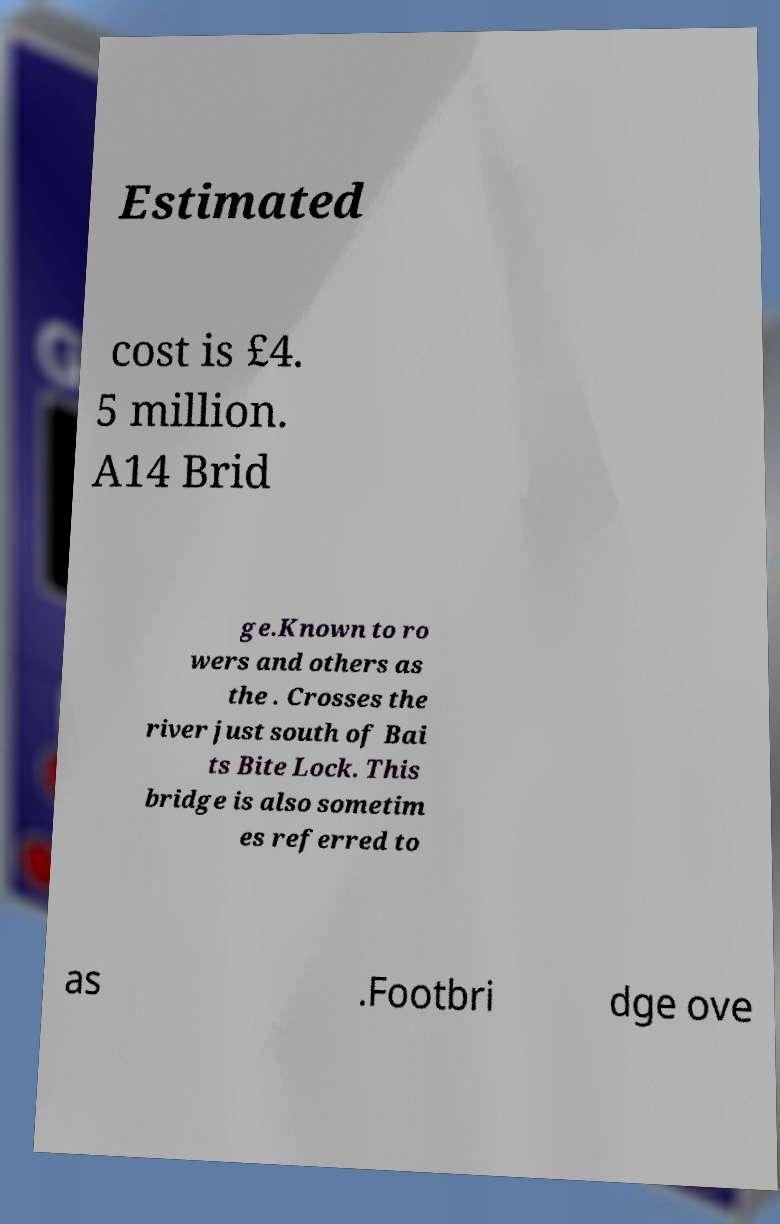There's text embedded in this image that I need extracted. Can you transcribe it verbatim? Estimated cost is £4. 5 million. A14 Brid ge.Known to ro wers and others as the . Crosses the river just south of Bai ts Bite Lock. This bridge is also sometim es referred to as .Footbri dge ove 